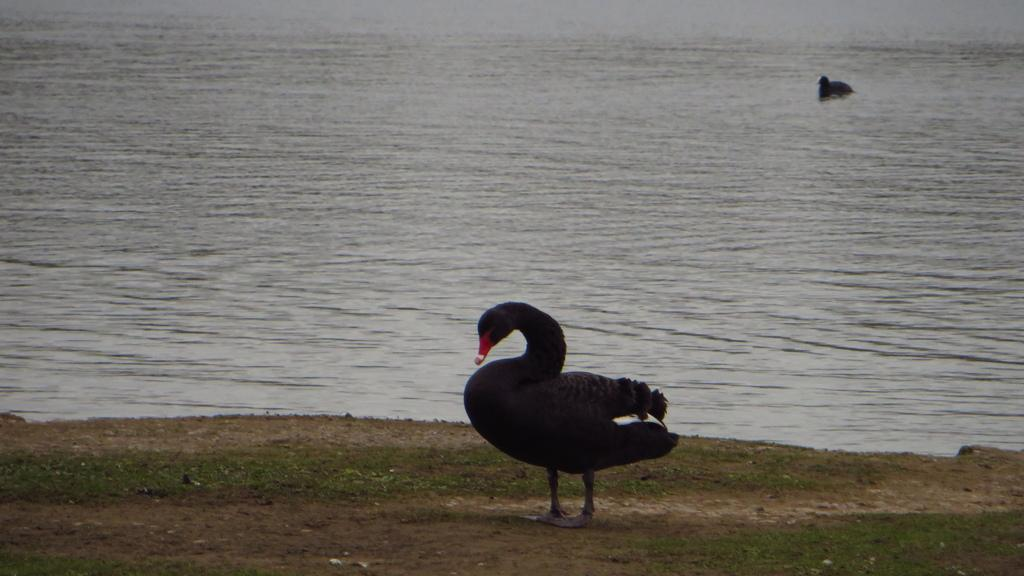What type of animal can be seen in the image? There is a bird in the image. Can you describe the background of the image? The background includes water. Are there any other birds visible in the image? Yes, there is another bird in the background of the image. What type of yarn is the bird using to weave a rule in the image? There is no yarn or rule present in the image; it features a bird and a background with water. 